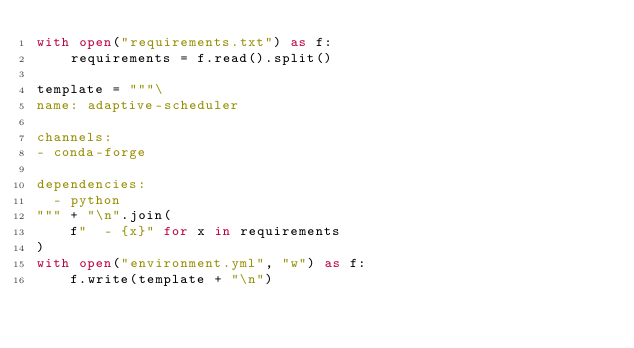Convert code to text. <code><loc_0><loc_0><loc_500><loc_500><_Python_>with open("requirements.txt") as f:
    requirements = f.read().split()

template = """\
name: adaptive-scheduler

channels:
- conda-forge

dependencies:
  - python
""" + "\n".join(
    f"  - {x}" for x in requirements
)
with open("environment.yml", "w") as f:
    f.write(template + "\n")
</code> 